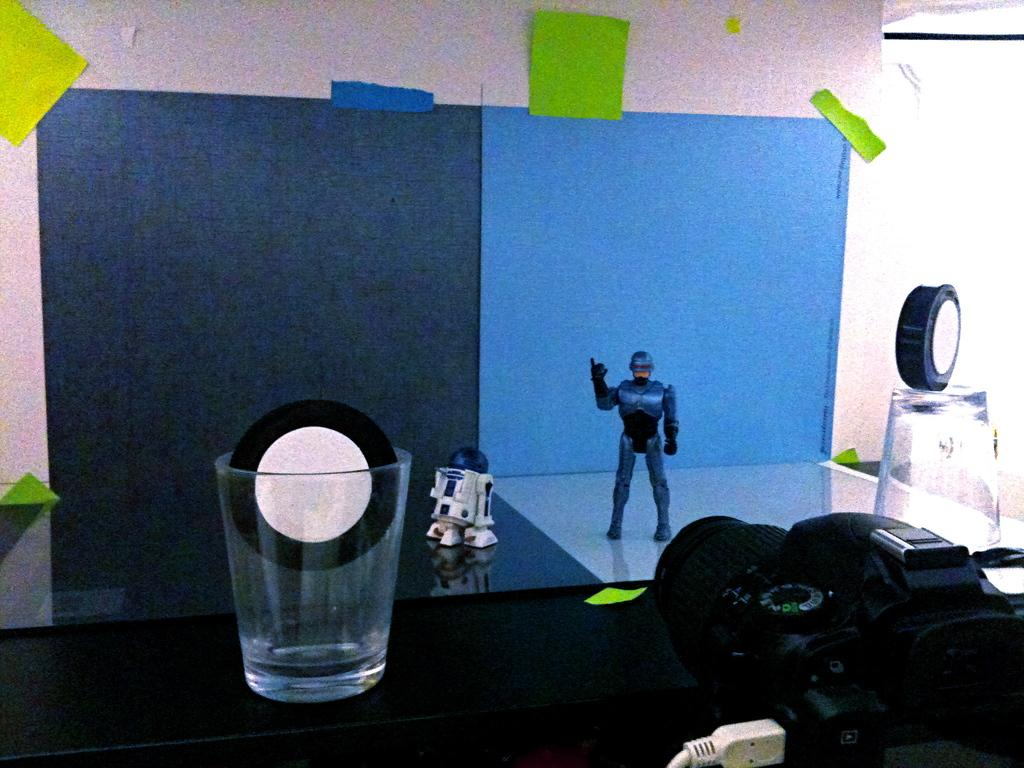What is the main piece of furniture in the image? There is a table in the image. What objects are placed on the table? There are glasses and a toy on the table. What can be seen on the wall in the background? There are charts on the wall in the background. What is the source of light in the background? Light is visible in the background. Where is the coach located in the image? There is no coach present in the image. What part of the body is visible in the image? The image does not show any body parts, including elbows. 